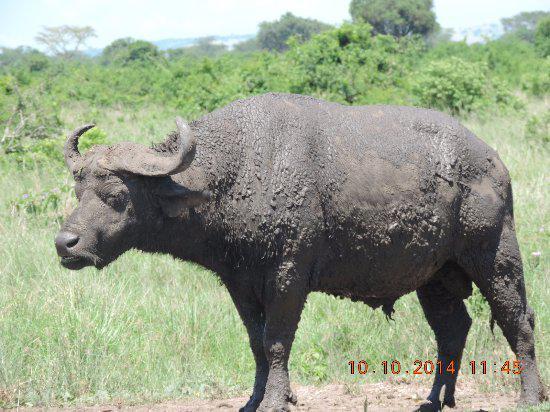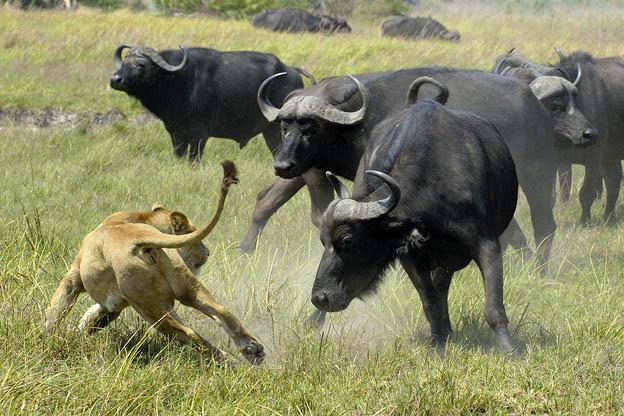The first image is the image on the left, the second image is the image on the right. Evaluate the accuracy of this statement regarding the images: "One of the images contains an animal that is not a water buffalo.". Is it true? Answer yes or no. Yes. The first image is the image on the left, the second image is the image on the right. Analyze the images presented: Is the assertion "There are at least five water buffalo." valid? Answer yes or no. Yes. 